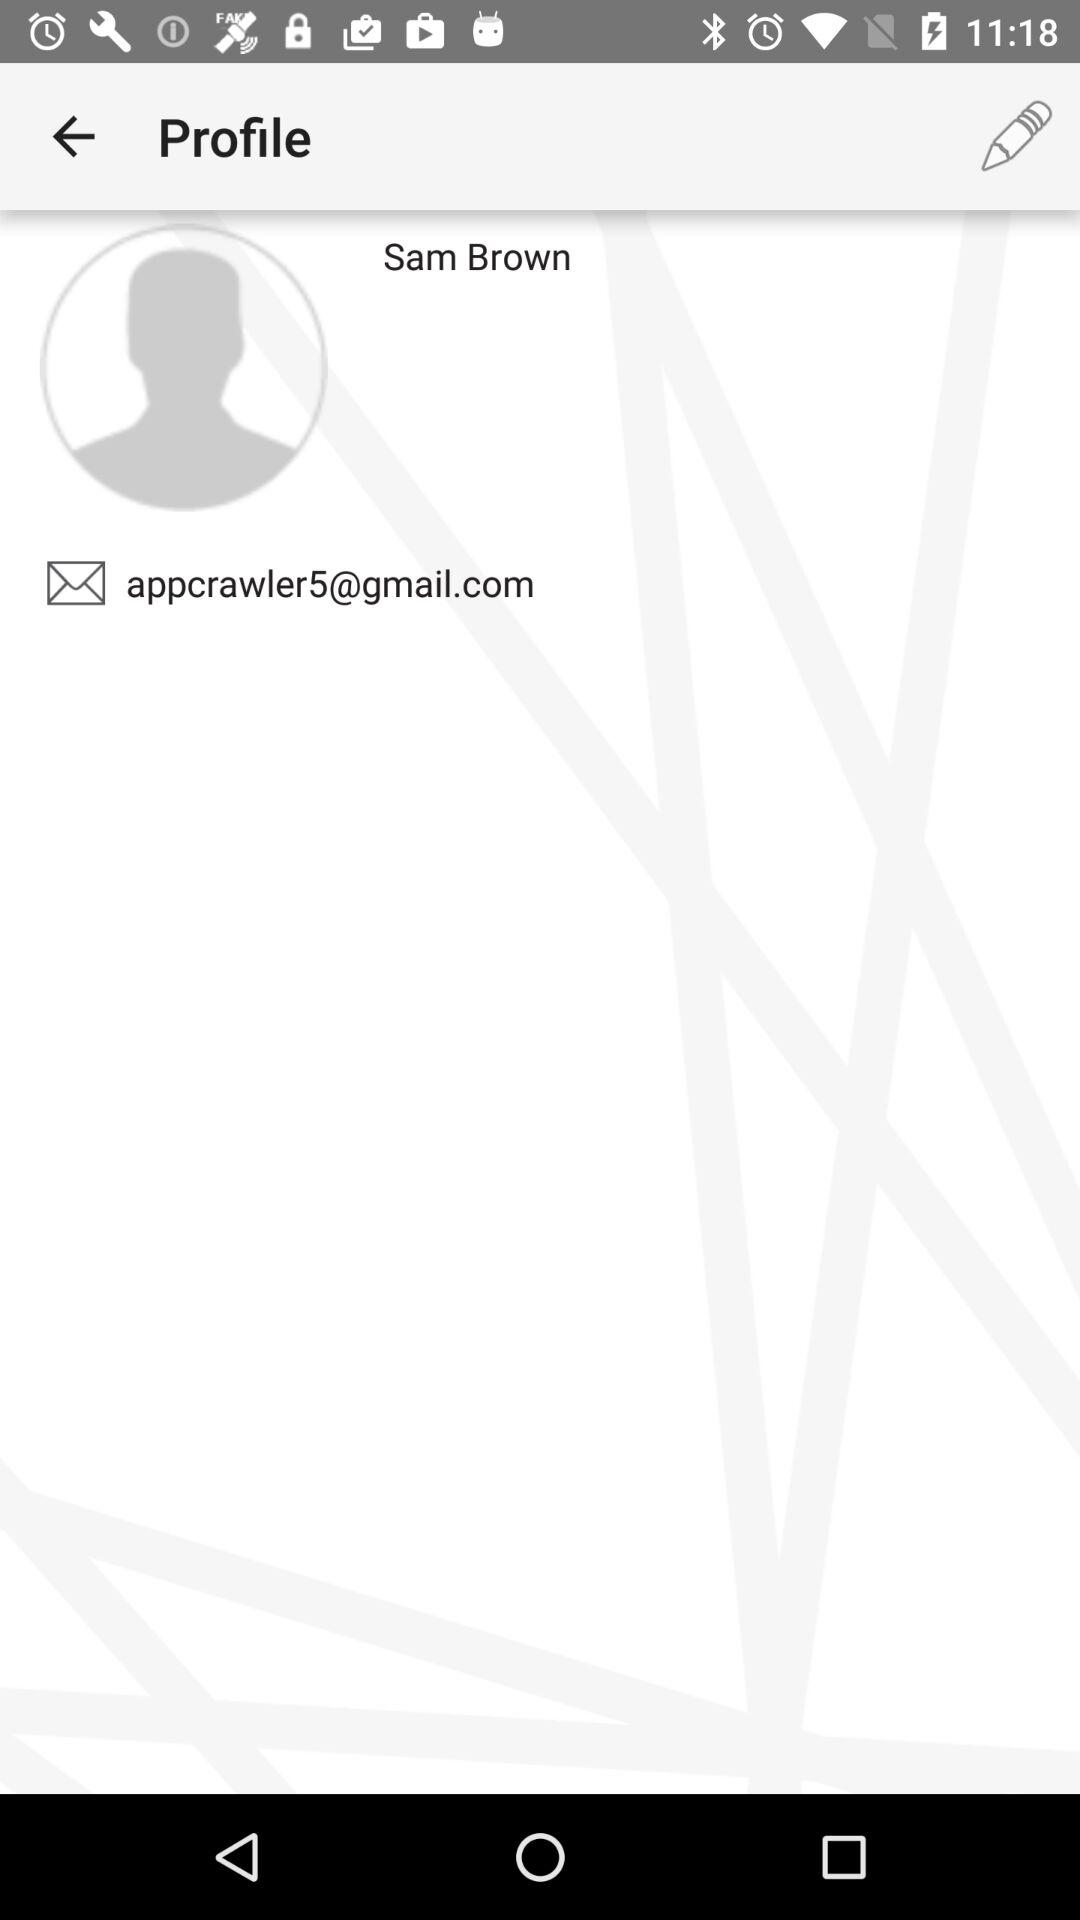What is the user name? The user name is Sam Brown. 